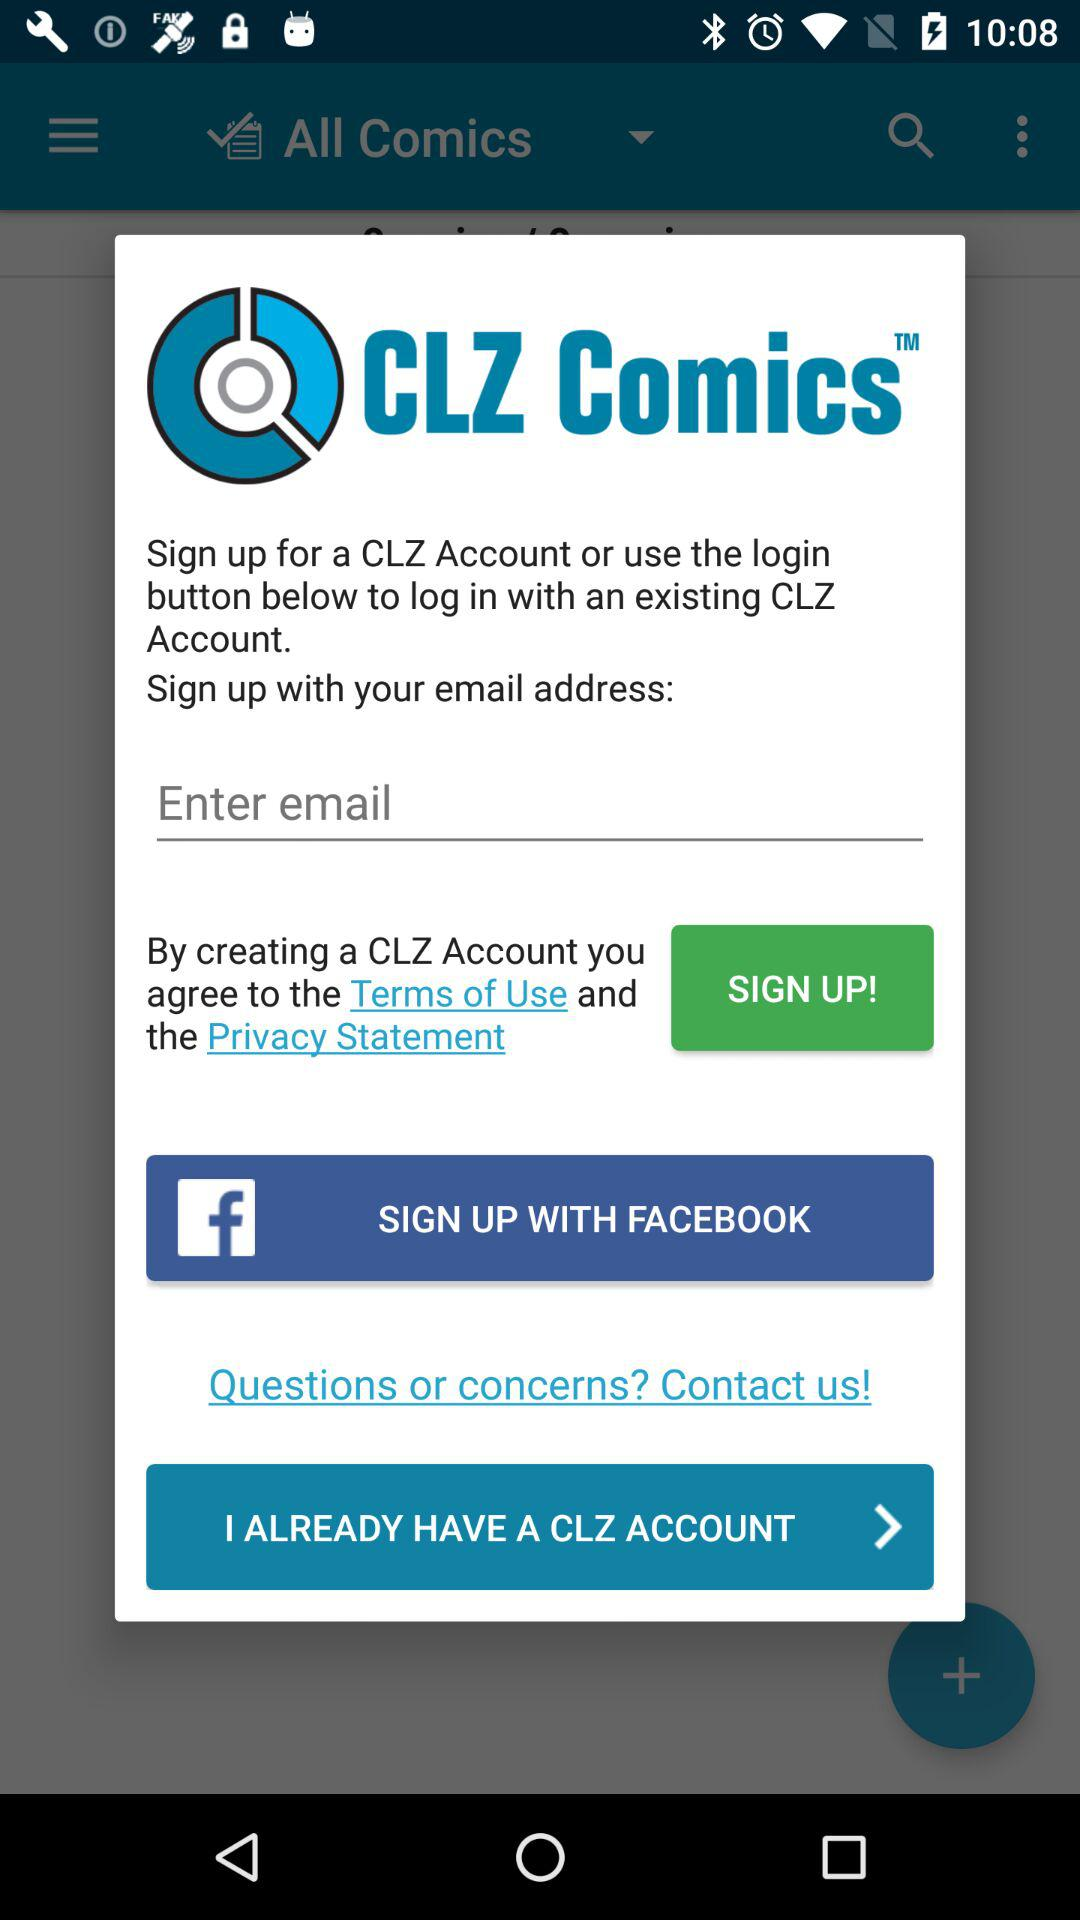Does the user already have a "CLZ" account?
When the provided information is insufficient, respond with <no answer>. <no answer> 